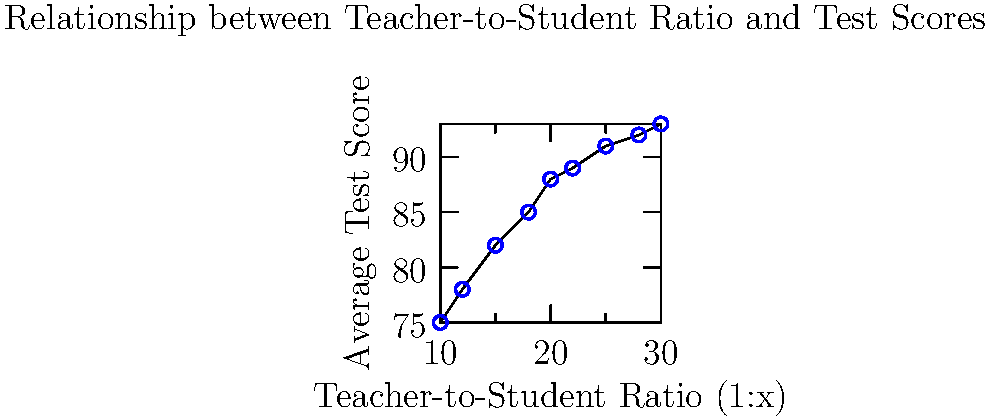Based on the scatter plot showing the relationship between teacher-to-student ratios and average test scores in early childhood education settings, what general trend can be observed? How might this information impact policy recommendations for optimal class sizes in ECE programs? To analyze the scatter plot and draw conclusions:

1. Observe the overall pattern: As we move from left to right (increasing teacher-to-student ratio), the average test scores tend to increase.

2. Relationship type: The relationship appears to be positive, meaning that as the teacher-to-student ratio increases (i.e., more students per teacher), test scores tend to improve.

3. Strength of relationship: The points form a relatively clear upward trend, suggesting a moderately strong positive correlation.

4. Non-linearity: The relationship seems to flatten out somewhat at higher ratios, indicating diminishing returns.

5. Policy implications:
   a. Contrary to common belief, larger class sizes (higher ratios) seem to correlate with better test scores in this data set.
   b. This could suggest that other factors (e.g., teaching methods, resources) might be more influential than class size alone.
   c. However, we should be cautious about recommending very large class sizes, as the benefits appear to level off at higher ratios.

6. Considerations for ECE programs:
   a. Focus on teacher quality and resources rather than solely on reducing class sizes.
   b. Investigate optimal ratio range (e.g., 1:20 to 1:25) where benefits are significant but before diminishing returns set in.
   c. Consider other factors not shown in this data, such as individual student needs, teacher workload, and non-academic outcomes.

7. Limitations:
   a. Correlation does not imply causation; other factors may be influencing this relationship.
   b. The data is limited to test scores and doesn't account for other important aspects of child development.
   c. The specific context of these measurements (e.g., age group, type of tests) is not provided.

In conclusion, while the data suggests that larger class sizes correlate with better test scores, a nuanced approach considering multiple factors is necessary when making policy recommendations for ECE programs.
Answer: Positive correlation between teacher-to-student ratio and test scores, with diminishing returns at higher ratios, suggesting focus on teacher quality and optimal ratio range rather than minimizing class sizes. 